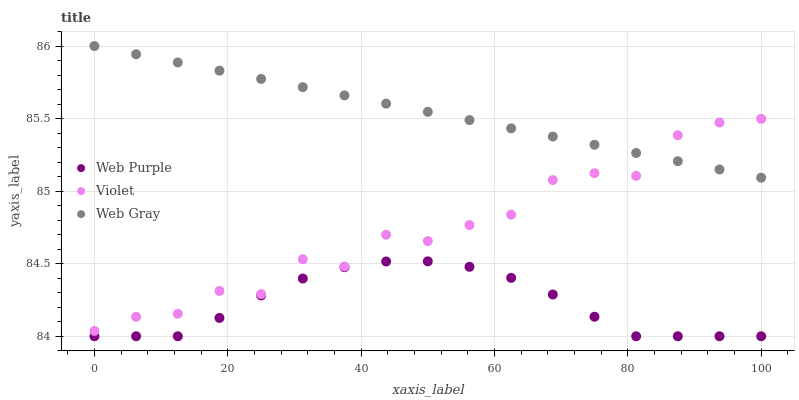Does Web Purple have the minimum area under the curve?
Answer yes or no. Yes. Does Web Gray have the maximum area under the curve?
Answer yes or no. Yes. Does Violet have the minimum area under the curve?
Answer yes or no. No. Does Violet have the maximum area under the curve?
Answer yes or no. No. Is Web Gray the smoothest?
Answer yes or no. Yes. Is Violet the roughest?
Answer yes or no. Yes. Is Violet the smoothest?
Answer yes or no. No. Is Web Gray the roughest?
Answer yes or no. No. Does Web Purple have the lowest value?
Answer yes or no. Yes. Does Violet have the lowest value?
Answer yes or no. No. Does Web Gray have the highest value?
Answer yes or no. Yes. Does Violet have the highest value?
Answer yes or no. No. Is Web Purple less than Violet?
Answer yes or no. Yes. Is Web Gray greater than Web Purple?
Answer yes or no. Yes. Does Web Gray intersect Violet?
Answer yes or no. Yes. Is Web Gray less than Violet?
Answer yes or no. No. Is Web Gray greater than Violet?
Answer yes or no. No. Does Web Purple intersect Violet?
Answer yes or no. No. 